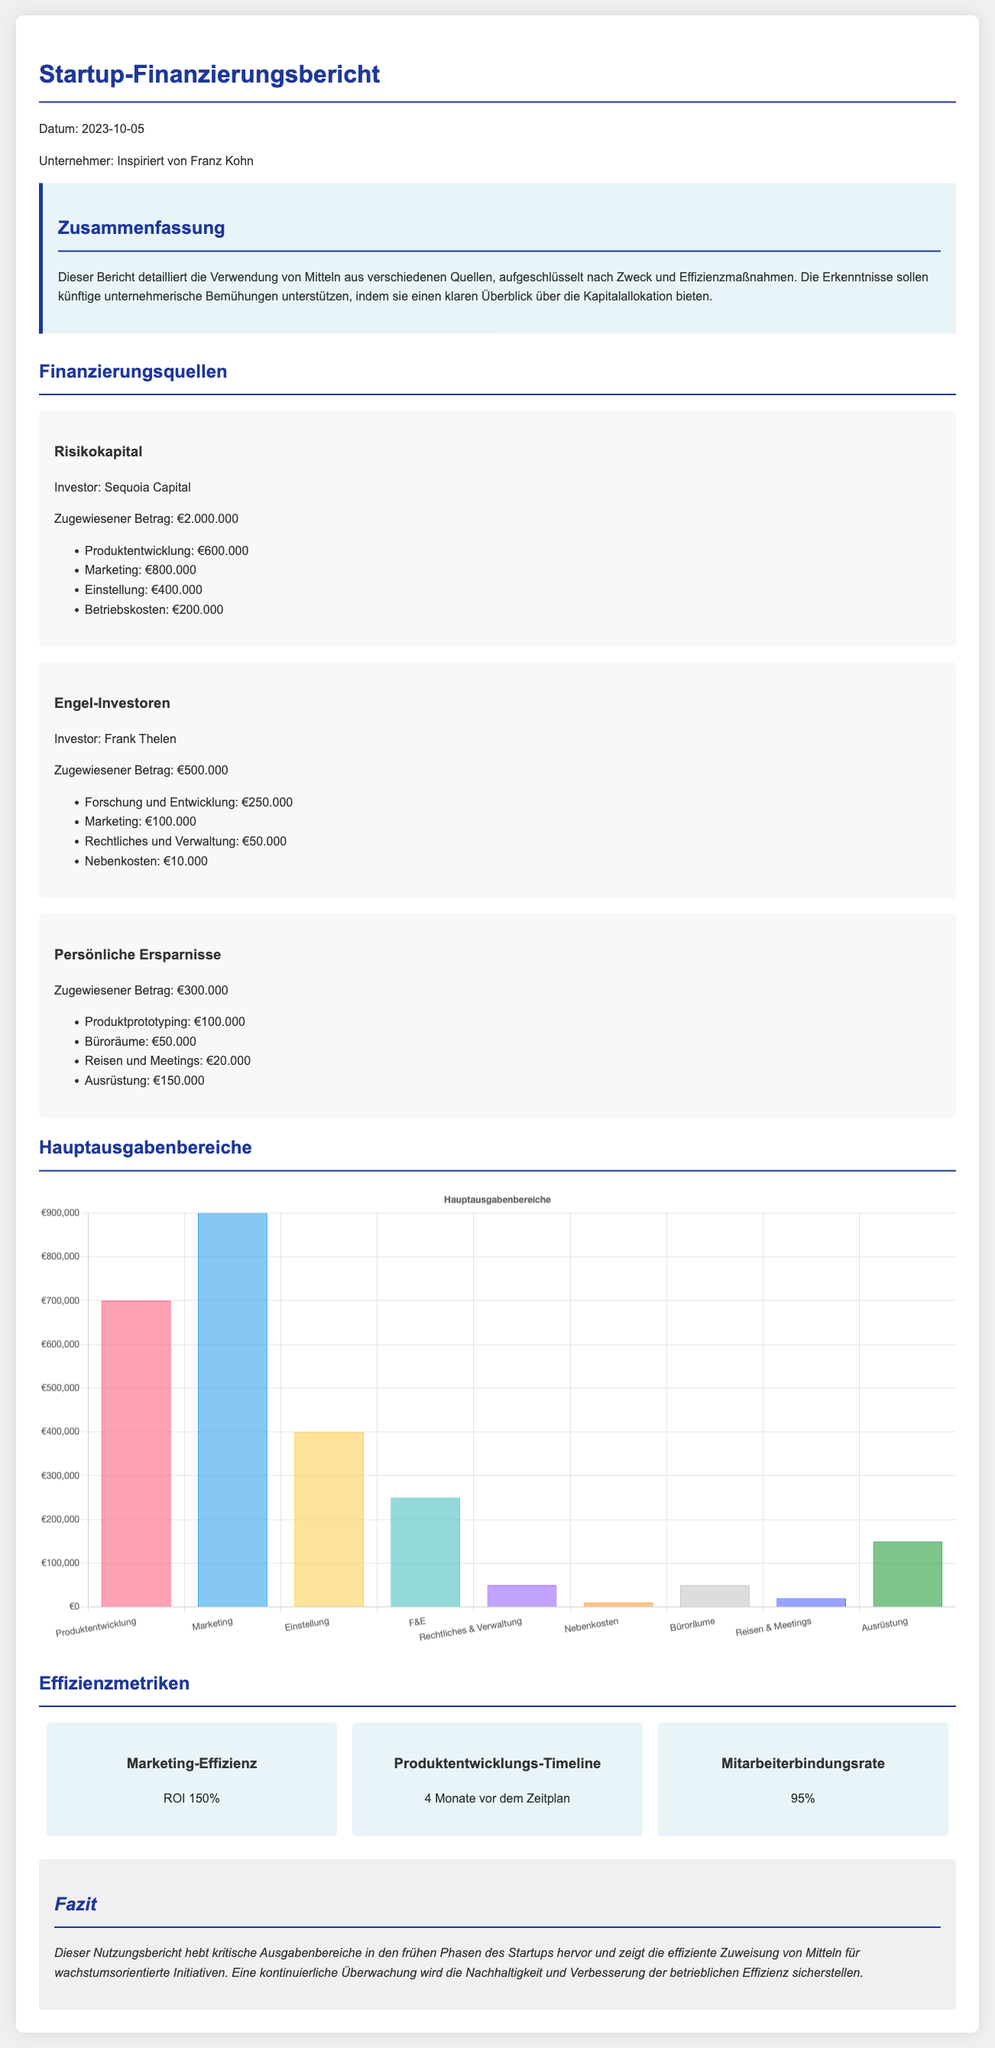What is the total allocated amount from venture capital? The total allocated amount from venture capital as specified in the document is €2.000.000.
Answer: €2.000.000 Who is the angel investor mentioned in the report? The document explicitly states that the angel investor is Frank Thelen.
Answer: Frank Thelen What percentage of the funds was allocated to marketing from venture capital? The marketing allocation from venture capital is €800.000 out of €2.000.000, which calculates to 40%.
Answer: 40% How much was allocated for product prototyping from personal savings? The document indicates that €100.000 was allocated for product prototyping from personal savings.
Answer: €100.000 What is the ROI for marketing efficiency? The report states that the marketing efficiency ROI is 150%.
Answer: 150% How many months ahead is the product development timeline? According to the document, the product development timeline is 4 months ahead of schedule.
Answer: 4 Monate What is the total expenditure on marketing across all funding sources? The total expenditure on marketing is €800.000 from venture capital and €100.000 from angel investors, summing up to €900.000.
Answer: €900.000 What is highlighted in the conclusion for future monitoring? The conclusion emphasizes that continuous monitoring will ensure sustainability and improvement of operational efficiency.
Answer: Nachhaltigkeit und Verbesserung der betrieblichen Effizienz What major purpose had the highest expenditures? The major purpose with the highest expenditures indicated in the spending chart is marketing, with total expenditures of €900.000.
Answer: Marketing 